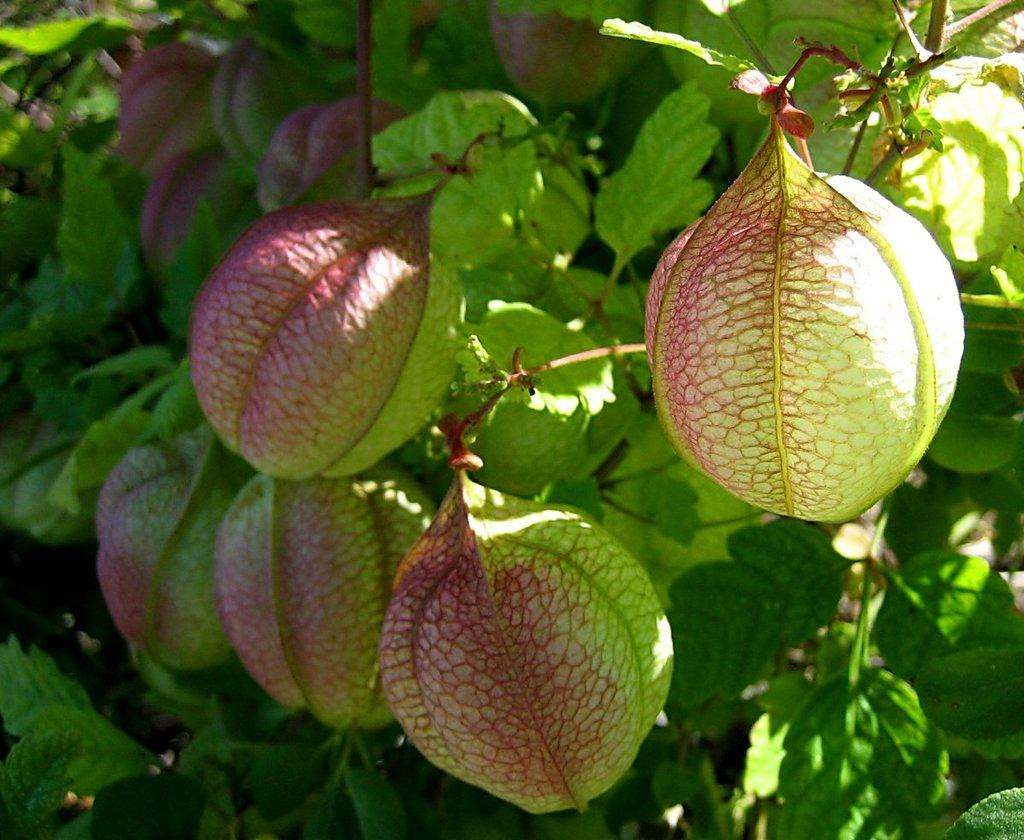What type of vegetation can be seen in the image? There are leaves and balloon vine in the image. Can you describe the balloon vine in more detail? The balloon vine is a type of plant with distinctive inflated pods that resemble balloons. How many frogs are sitting on the clover in the image? There are no frogs or clover present in the image; it only features leaves and balloon vine. 